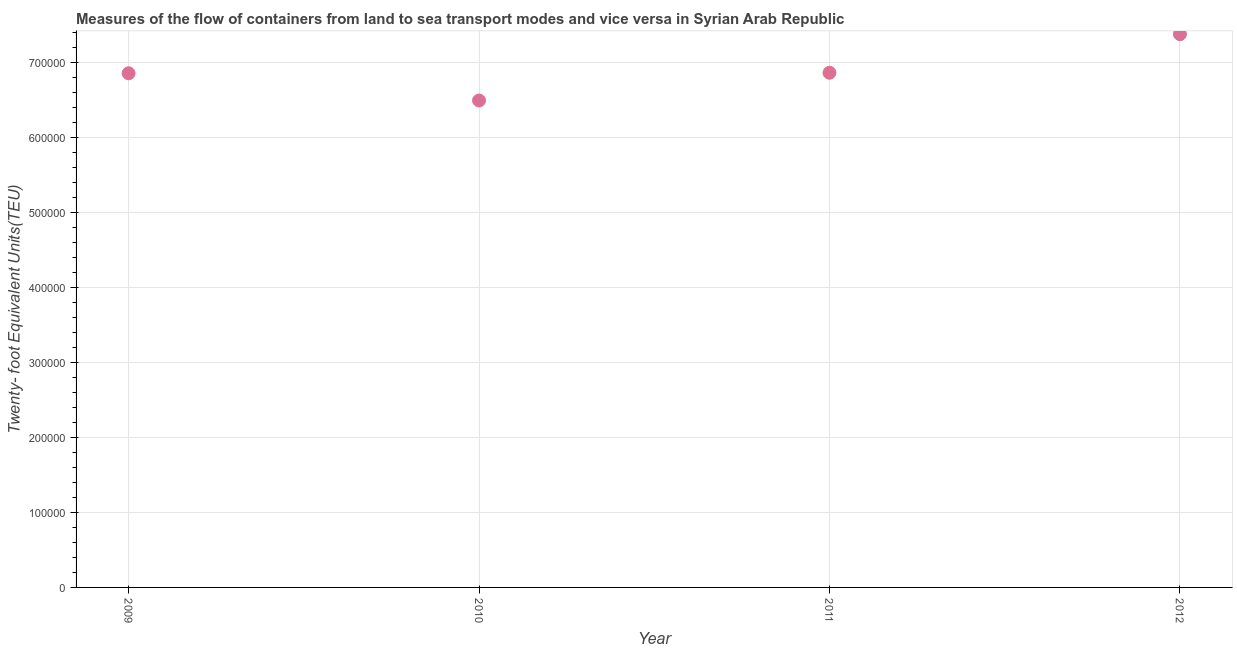What is the container port traffic in 2009?
Give a very brief answer. 6.85e+05. Across all years, what is the maximum container port traffic?
Ensure brevity in your answer.  7.37e+05. Across all years, what is the minimum container port traffic?
Make the answer very short. 6.49e+05. In which year was the container port traffic maximum?
Ensure brevity in your answer.  2012. What is the sum of the container port traffic?
Give a very brief answer. 2.76e+06. What is the difference between the container port traffic in 2011 and 2012?
Make the answer very short. -5.14e+04. What is the average container port traffic per year?
Provide a short and direct response. 6.89e+05. What is the median container port traffic?
Your response must be concise. 6.86e+05. In how many years, is the container port traffic greater than 80000 TEU?
Make the answer very short. 4. Do a majority of the years between 2009 and 2010 (inclusive) have container port traffic greater than 640000 TEU?
Offer a terse response. Yes. What is the ratio of the container port traffic in 2009 to that in 2012?
Provide a succinct answer. 0.93. Is the container port traffic in 2009 less than that in 2011?
Keep it short and to the point. Yes. What is the difference between the highest and the second highest container port traffic?
Offer a very short reply. 5.14e+04. Is the sum of the container port traffic in 2010 and 2012 greater than the maximum container port traffic across all years?
Your answer should be compact. Yes. What is the difference between the highest and the lowest container port traffic?
Give a very brief answer. 8.84e+04. In how many years, is the container port traffic greater than the average container port traffic taken over all years?
Offer a very short reply. 1. How many dotlines are there?
Provide a succinct answer. 1. Are the values on the major ticks of Y-axis written in scientific E-notation?
Provide a succinct answer. No. What is the title of the graph?
Keep it short and to the point. Measures of the flow of containers from land to sea transport modes and vice versa in Syrian Arab Republic. What is the label or title of the X-axis?
Provide a short and direct response. Year. What is the label or title of the Y-axis?
Keep it short and to the point. Twenty- foot Equivalent Units(TEU). What is the Twenty- foot Equivalent Units(TEU) in 2009?
Offer a terse response. 6.85e+05. What is the Twenty- foot Equivalent Units(TEU) in 2010?
Make the answer very short. 6.49e+05. What is the Twenty- foot Equivalent Units(TEU) in 2011?
Your answer should be compact. 6.86e+05. What is the Twenty- foot Equivalent Units(TEU) in 2012?
Offer a very short reply. 7.37e+05. What is the difference between the Twenty- foot Equivalent Units(TEU) in 2009 and 2010?
Keep it short and to the point. 3.63e+04. What is the difference between the Twenty- foot Equivalent Units(TEU) in 2009 and 2011?
Provide a short and direct response. -699.28. What is the difference between the Twenty- foot Equivalent Units(TEU) in 2009 and 2012?
Your answer should be very brief. -5.21e+04. What is the difference between the Twenty- foot Equivalent Units(TEU) in 2010 and 2011?
Give a very brief answer. -3.70e+04. What is the difference between the Twenty- foot Equivalent Units(TEU) in 2010 and 2012?
Your answer should be very brief. -8.84e+04. What is the difference between the Twenty- foot Equivalent Units(TEU) in 2011 and 2012?
Your response must be concise. -5.14e+04. What is the ratio of the Twenty- foot Equivalent Units(TEU) in 2009 to that in 2010?
Offer a very short reply. 1.06. What is the ratio of the Twenty- foot Equivalent Units(TEU) in 2009 to that in 2011?
Give a very brief answer. 1. What is the ratio of the Twenty- foot Equivalent Units(TEU) in 2009 to that in 2012?
Your response must be concise. 0.93. What is the ratio of the Twenty- foot Equivalent Units(TEU) in 2010 to that in 2011?
Your answer should be very brief. 0.95. 